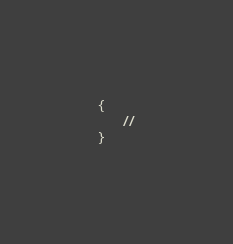Convert code to text. <code><loc_0><loc_0><loc_500><loc_500><_PHP_>{
    //
}
</code> 